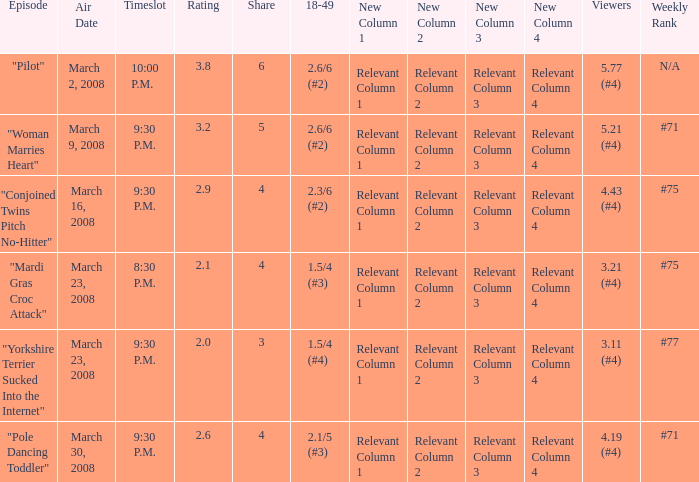What is the total ratings on share less than 4? 1.0. 